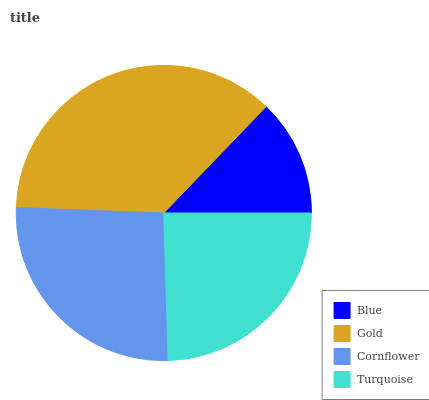Is Blue the minimum?
Answer yes or no. Yes. Is Gold the maximum?
Answer yes or no. Yes. Is Cornflower the minimum?
Answer yes or no. No. Is Cornflower the maximum?
Answer yes or no. No. Is Gold greater than Cornflower?
Answer yes or no. Yes. Is Cornflower less than Gold?
Answer yes or no. Yes. Is Cornflower greater than Gold?
Answer yes or no. No. Is Gold less than Cornflower?
Answer yes or no. No. Is Cornflower the high median?
Answer yes or no. Yes. Is Turquoise the low median?
Answer yes or no. Yes. Is Blue the high median?
Answer yes or no. No. Is Gold the low median?
Answer yes or no. No. 